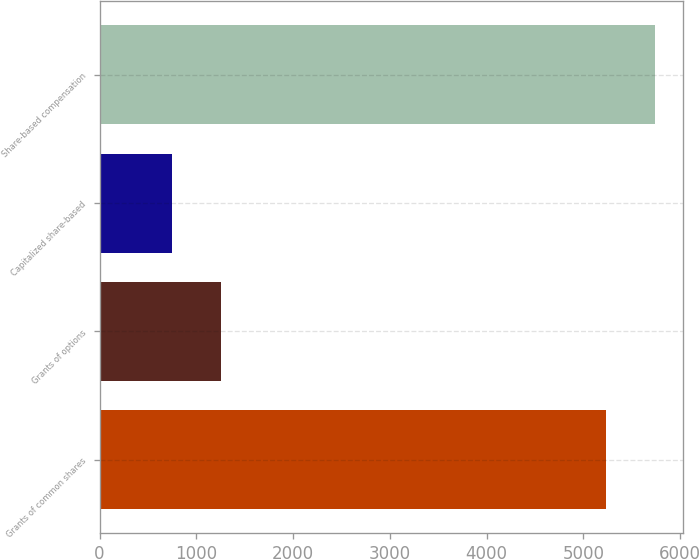Convert chart. <chart><loc_0><loc_0><loc_500><loc_500><bar_chart><fcel>Grants of common shares<fcel>Grants of options<fcel>Capitalized share-based<fcel>Share-based compensation<nl><fcel>5232<fcel>1255<fcel>745<fcel>5742<nl></chart> 